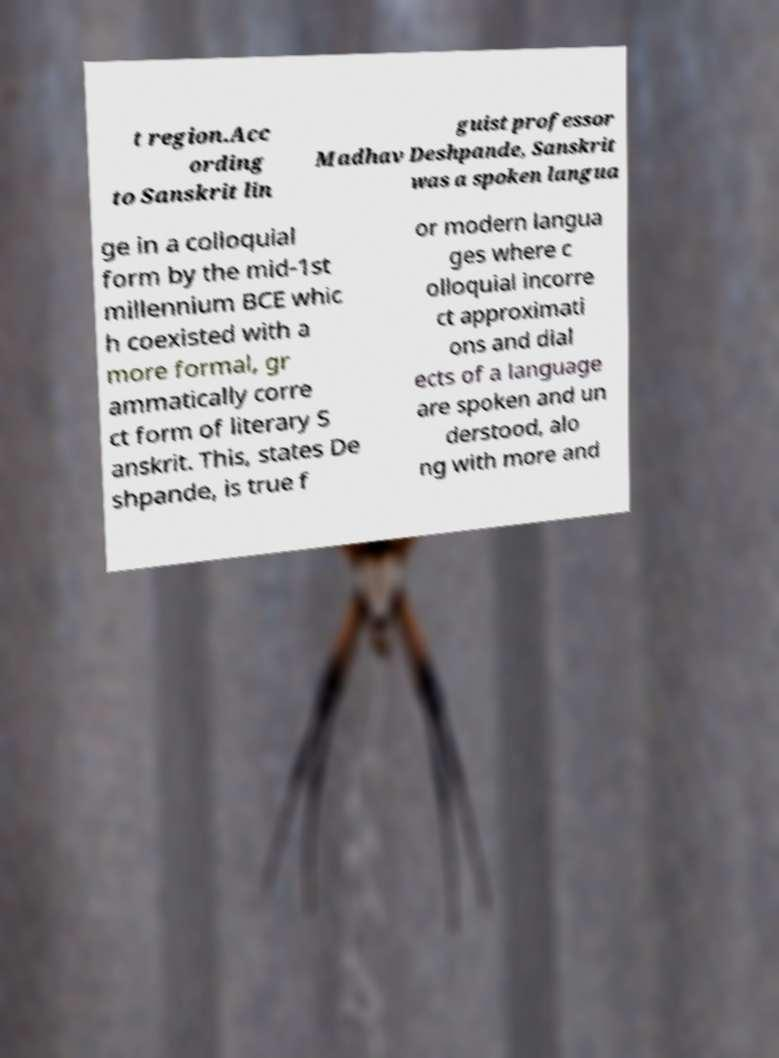Can you read and provide the text displayed in the image?This photo seems to have some interesting text. Can you extract and type it out for me? t region.Acc ording to Sanskrit lin guist professor Madhav Deshpande, Sanskrit was a spoken langua ge in a colloquial form by the mid-1st millennium BCE whic h coexisted with a more formal, gr ammatically corre ct form of literary S anskrit. This, states De shpande, is true f or modern langua ges where c olloquial incorre ct approximati ons and dial ects of a language are spoken and un derstood, alo ng with more and 